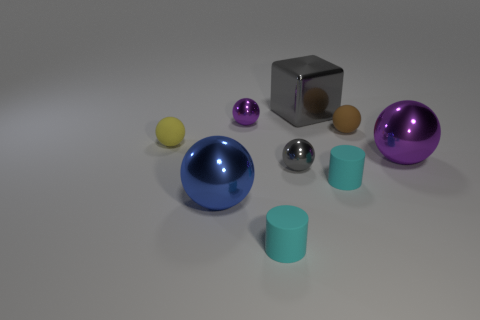Add 1 big balls. How many objects exist? 10 Subtract all brown balls. How many balls are left? 5 Subtract all brown spheres. How many spheres are left? 5 Subtract all balls. How many objects are left? 3 Subtract 1 cylinders. How many cylinders are left? 1 Subtract all gray cubes. How many green cylinders are left? 0 Subtract all small rubber cylinders. Subtract all rubber spheres. How many objects are left? 5 Add 8 small gray shiny balls. How many small gray shiny balls are left? 9 Add 6 small cyan rubber objects. How many small cyan rubber objects exist? 8 Subtract 1 yellow spheres. How many objects are left? 8 